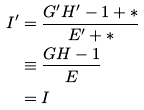Convert formula to latex. <formula><loc_0><loc_0><loc_500><loc_500>I ^ { \prime } & = \frac { G ^ { \prime } H ^ { \prime } - 1 + * } { E ^ { \prime } + * } \\ & \equiv \frac { G H - 1 } { E } \\ & = I</formula> 